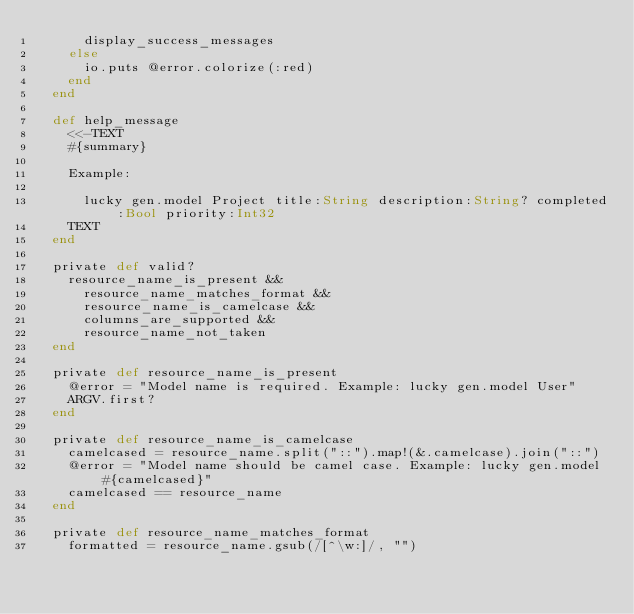<code> <loc_0><loc_0><loc_500><loc_500><_Crystal_>      display_success_messages
    else
      io.puts @error.colorize(:red)
    end
  end

  def help_message
    <<-TEXT
    #{summary}

    Example:

      lucky gen.model Project title:String description:String? completed:Bool priority:Int32
    TEXT
  end

  private def valid?
    resource_name_is_present &&
      resource_name_matches_format &&
      resource_name_is_camelcase &&
      columns_are_supported &&
      resource_name_not_taken
  end

  private def resource_name_is_present
    @error = "Model name is required. Example: lucky gen.model User"
    ARGV.first?
  end

  private def resource_name_is_camelcase
    camelcased = resource_name.split("::").map!(&.camelcase).join("::")
    @error = "Model name should be camel case. Example: lucky gen.model #{camelcased}"
    camelcased == resource_name
  end

  private def resource_name_matches_format
    formatted = resource_name.gsub(/[^\w:]/, "")</code> 